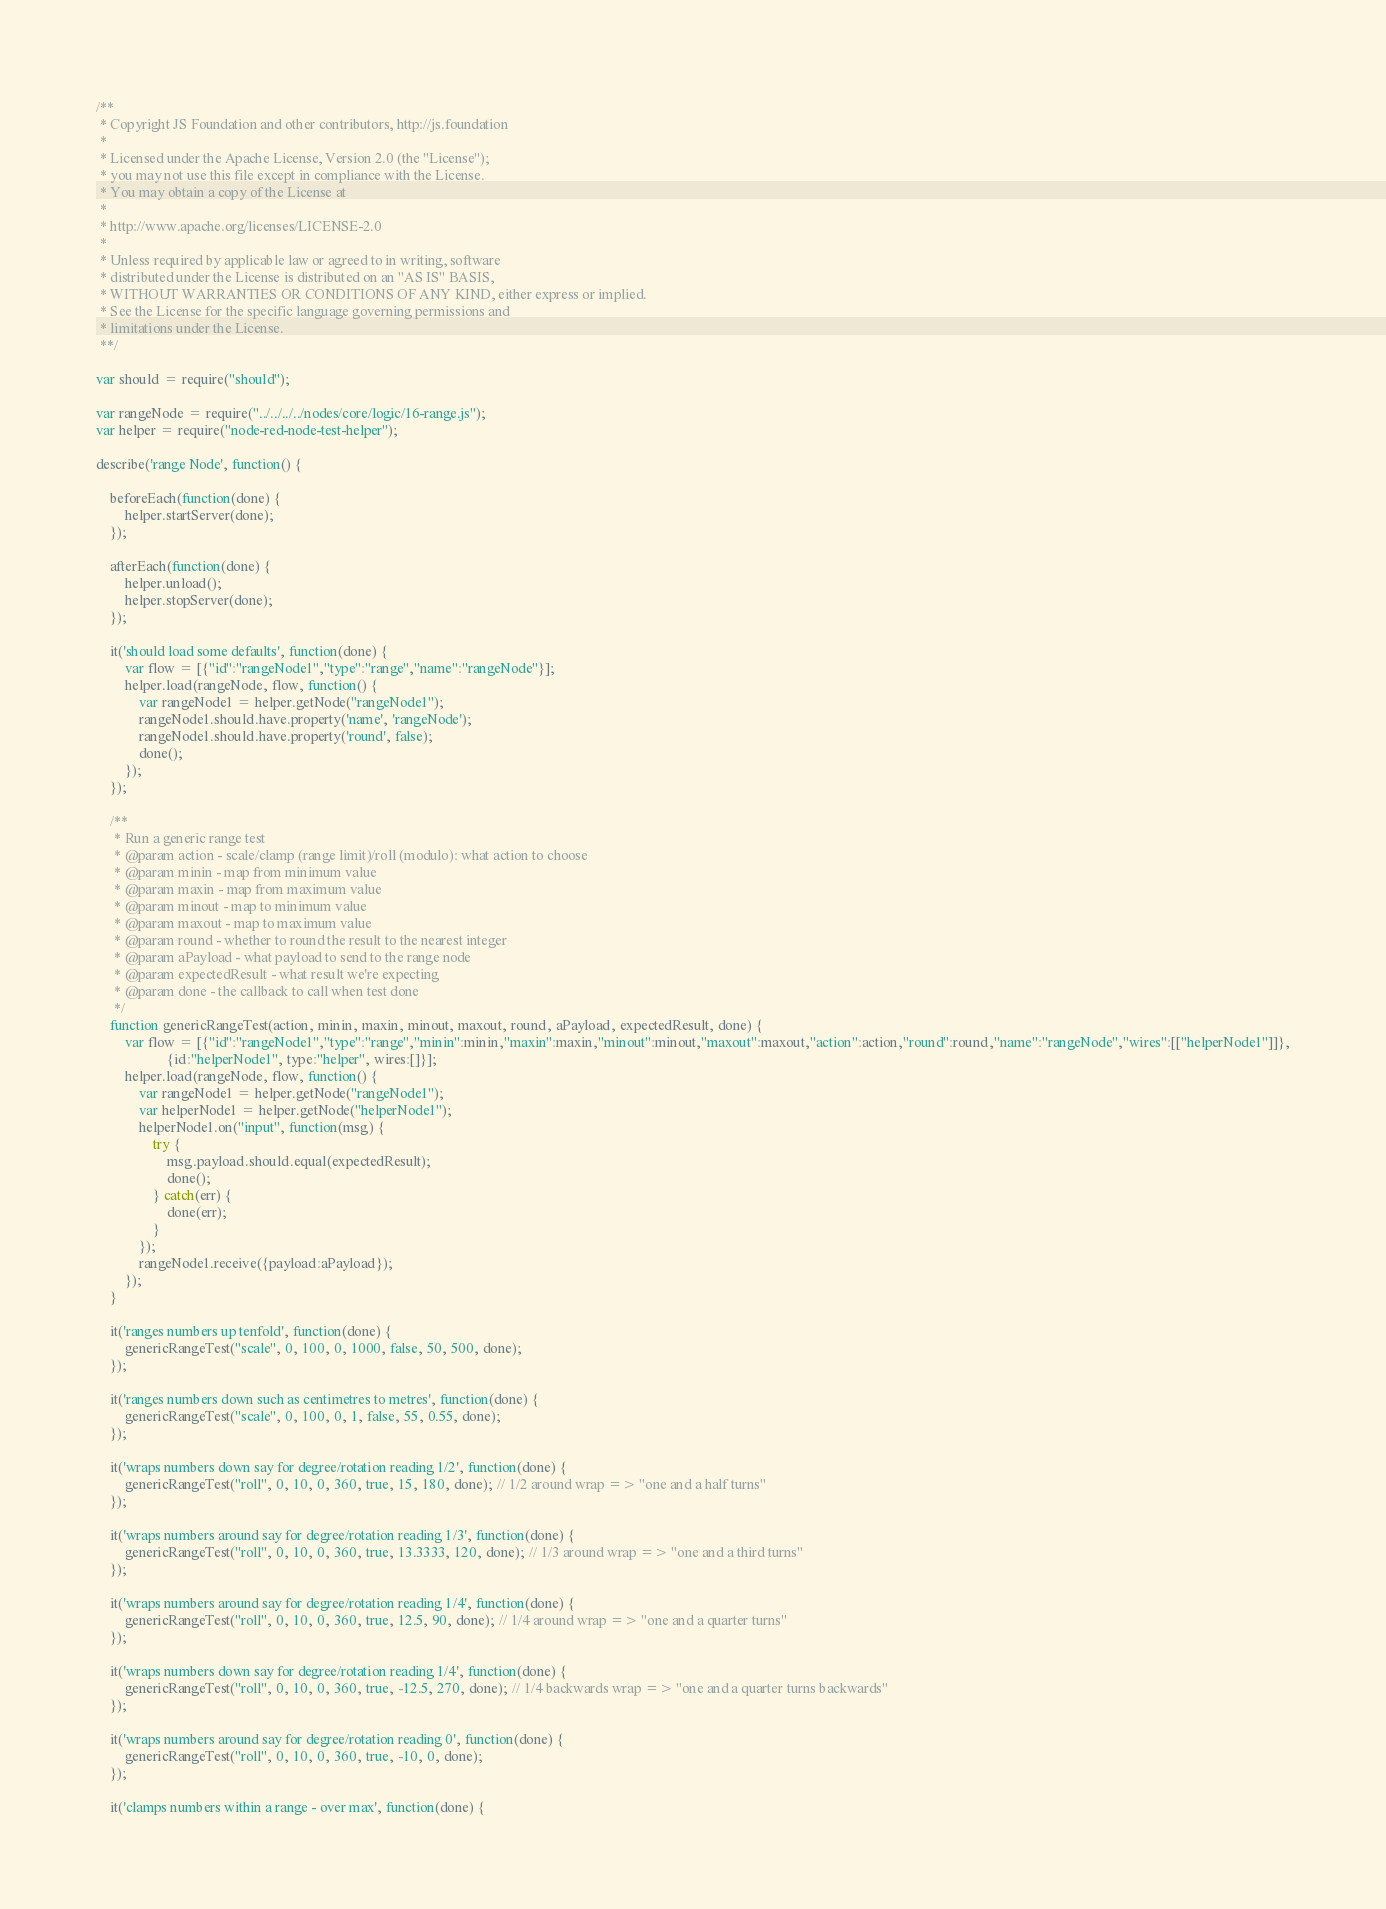<code> <loc_0><loc_0><loc_500><loc_500><_JavaScript_>/**
 * Copyright JS Foundation and other contributors, http://js.foundation
 *
 * Licensed under the Apache License, Version 2.0 (the "License");
 * you may not use this file except in compliance with the License.
 * You may obtain a copy of the License at
 *
 * http://www.apache.org/licenses/LICENSE-2.0
 *
 * Unless required by applicable law or agreed to in writing, software
 * distributed under the License is distributed on an "AS IS" BASIS,
 * WITHOUT WARRANTIES OR CONDITIONS OF ANY KIND, either express or implied.
 * See the License for the specific language governing permissions and
 * limitations under the License.
 **/

var should = require("should");

var rangeNode = require("../../../../nodes/core/logic/16-range.js");
var helper = require("node-red-node-test-helper");

describe('range Node', function() {

    beforeEach(function(done) {
        helper.startServer(done);
    });

    afterEach(function(done) {
        helper.unload();
        helper.stopServer(done);
    });

    it('should load some defaults', function(done) {
        var flow = [{"id":"rangeNode1","type":"range","name":"rangeNode"}];
        helper.load(rangeNode, flow, function() {
            var rangeNode1 = helper.getNode("rangeNode1");
            rangeNode1.should.have.property('name', 'rangeNode');
            rangeNode1.should.have.property('round', false);
            done();
        });
    });

    /**
     * Run a generic range test
     * @param action - scale/clamp (range limit)/roll (modulo): what action to choose
     * @param minin - map from minimum value
     * @param maxin - map from maximum value
     * @param minout - map to minimum value
     * @param maxout - map to maximum value
     * @param round - whether to round the result to the nearest integer
     * @param aPayload - what payload to send to the range node
     * @param expectedResult - what result we're expecting
     * @param done - the callback to call when test done
     */
    function genericRangeTest(action, minin, maxin, minout, maxout, round, aPayload, expectedResult, done) {
        var flow = [{"id":"rangeNode1","type":"range","minin":minin,"maxin":maxin,"minout":minout,"maxout":maxout,"action":action,"round":round,"name":"rangeNode","wires":[["helperNode1"]]},
                    {id:"helperNode1", type:"helper", wires:[]}];
        helper.load(rangeNode, flow, function() {
            var rangeNode1 = helper.getNode("rangeNode1");
            var helperNode1 = helper.getNode("helperNode1");
            helperNode1.on("input", function(msg) {
                try {
                    msg.payload.should.equal(expectedResult);
                    done();
                } catch(err) {
                    done(err);
                }
            });
            rangeNode1.receive({payload:aPayload});
        });
    }

    it('ranges numbers up tenfold', function(done) {
        genericRangeTest("scale", 0, 100, 0, 1000, false, 50, 500, done);
    });

    it('ranges numbers down such as centimetres to metres', function(done) {
        genericRangeTest("scale", 0, 100, 0, 1, false, 55, 0.55, done);
    });

    it('wraps numbers down say for degree/rotation reading 1/2', function(done) {
        genericRangeTest("roll", 0, 10, 0, 360, true, 15, 180, done); // 1/2 around wrap => "one and a half turns"
    });

    it('wraps numbers around say for degree/rotation reading 1/3', function(done) {
        genericRangeTest("roll", 0, 10, 0, 360, true, 13.3333, 120, done); // 1/3 around wrap => "one and a third turns"
    });

    it('wraps numbers around say for degree/rotation reading 1/4', function(done) {
        genericRangeTest("roll", 0, 10, 0, 360, true, 12.5, 90, done); // 1/4 around wrap => "one and a quarter turns"
    });

    it('wraps numbers down say for degree/rotation reading 1/4', function(done) {
        genericRangeTest("roll", 0, 10, 0, 360, true, -12.5, 270, done); // 1/4 backwards wrap => "one and a quarter turns backwards"
    });

    it('wraps numbers around say for degree/rotation reading 0', function(done) {
        genericRangeTest("roll", 0, 10, 0, 360, true, -10, 0, done);
    });

    it('clamps numbers within a range - over max', function(done) {</code> 